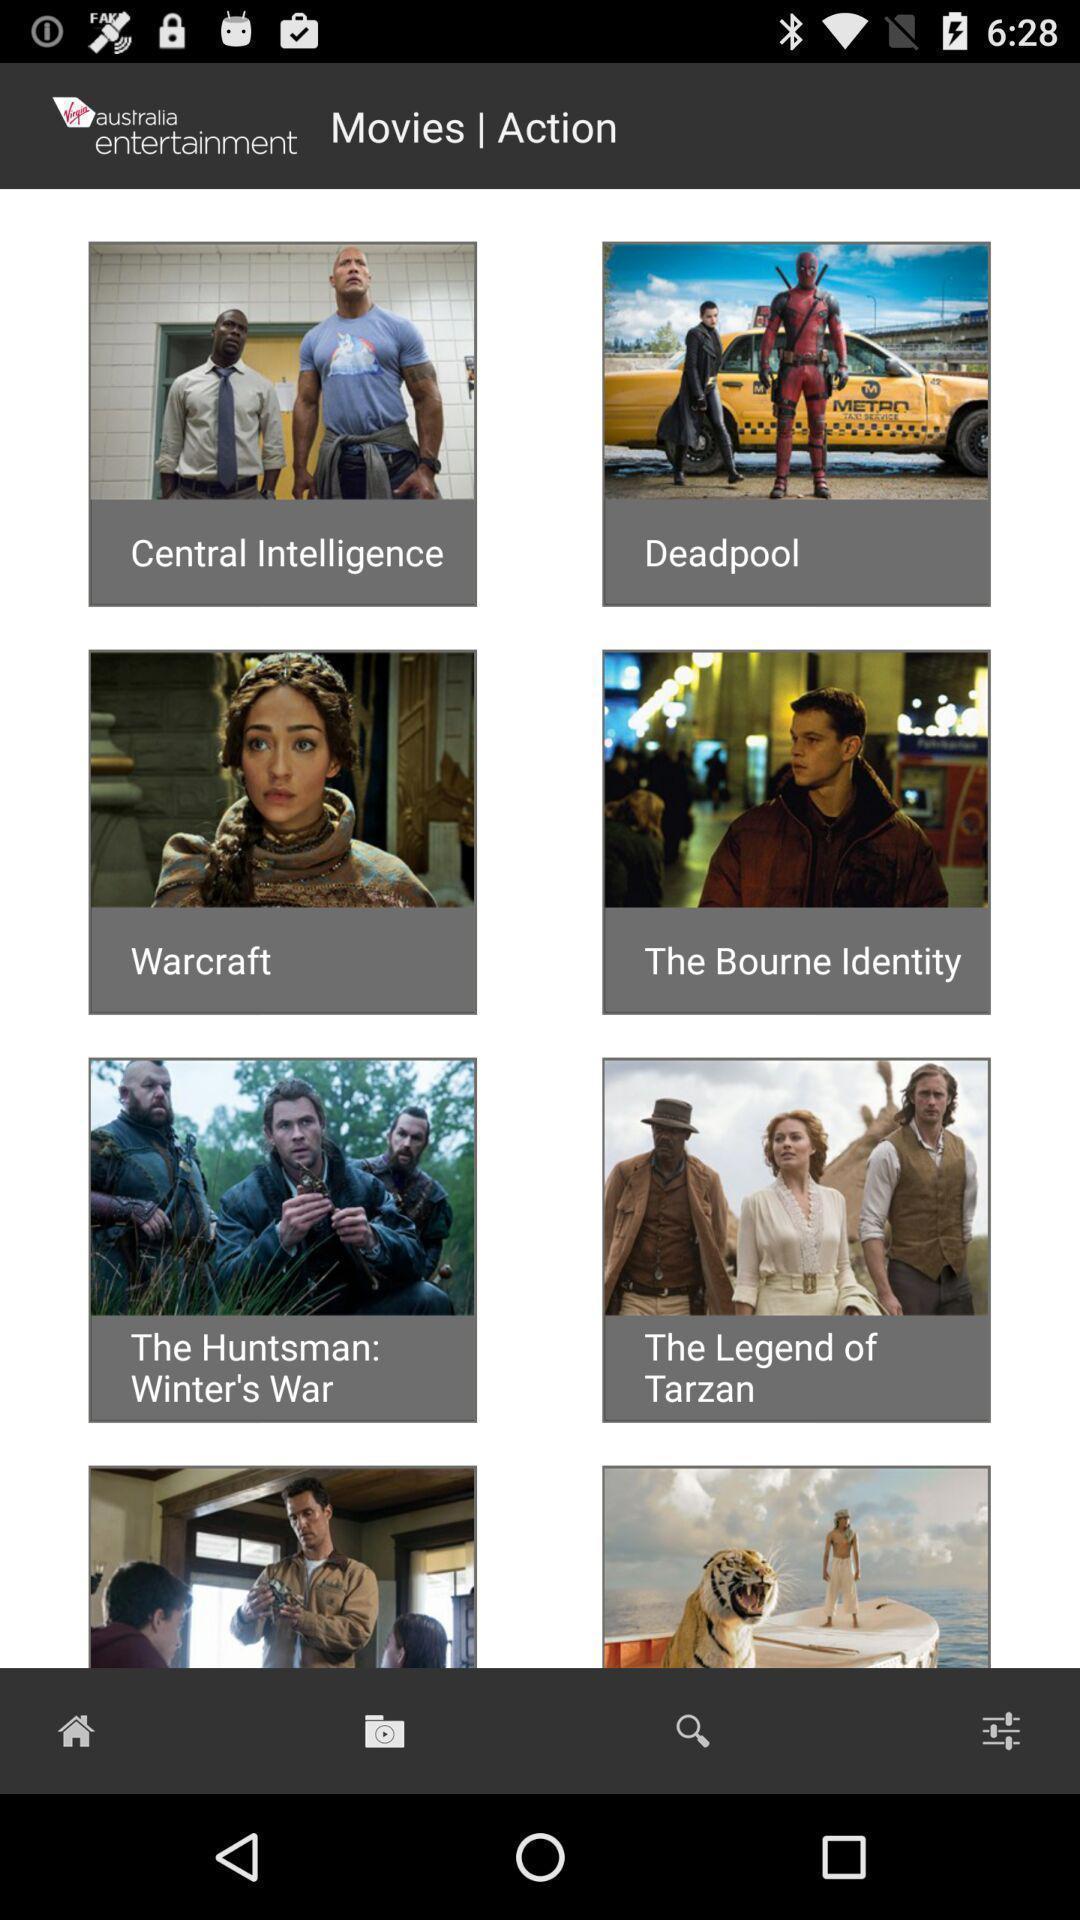What details can you identify in this image? Page of movies and action in australia entertainment. 